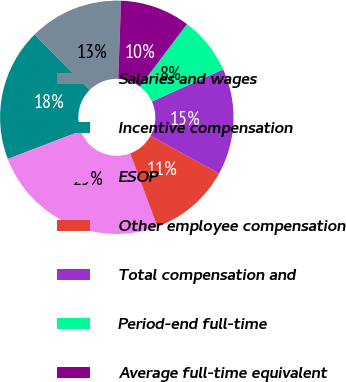Convert chart. <chart><loc_0><loc_0><loc_500><loc_500><pie_chart><fcel>Salaries and wages<fcel>Incentive compensation<fcel>ESOP<fcel>Other employee compensation<fcel>Total compensation and<fcel>Period-end full-time<fcel>Average full-time equivalent<nl><fcel>13.05%<fcel>18.35%<fcel>24.85%<fcel>11.36%<fcel>14.73%<fcel>7.99%<fcel>9.68%<nl></chart> 